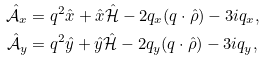<formula> <loc_0><loc_0><loc_500><loc_500>\hat { \mathcal { A } } _ { x } & = q ^ { 2 } \hat { x } + \hat { x } \hat { \mathcal { H } } - 2 q _ { x } ( q \cdot \hat { \rho } ) - 3 i q _ { x } , \\ \hat { \mathcal { A } } _ { y } & = q ^ { 2 } \hat { y } + \hat { y } \hat { \mathcal { H } } - 2 q _ { y } ( q \cdot \hat { \rho } ) - 3 i q _ { y } ,</formula> 